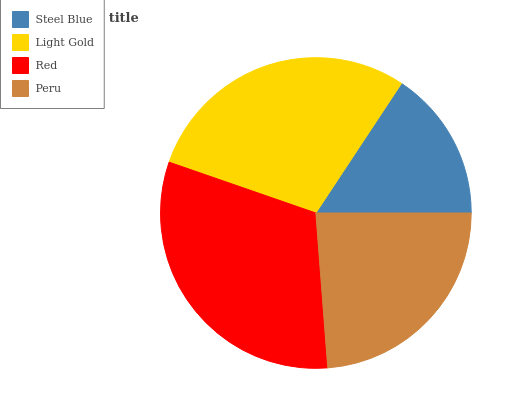Is Steel Blue the minimum?
Answer yes or no. Yes. Is Red the maximum?
Answer yes or no. Yes. Is Light Gold the minimum?
Answer yes or no. No. Is Light Gold the maximum?
Answer yes or no. No. Is Light Gold greater than Steel Blue?
Answer yes or no. Yes. Is Steel Blue less than Light Gold?
Answer yes or no. Yes. Is Steel Blue greater than Light Gold?
Answer yes or no. No. Is Light Gold less than Steel Blue?
Answer yes or no. No. Is Light Gold the high median?
Answer yes or no. Yes. Is Peru the low median?
Answer yes or no. Yes. Is Steel Blue the high median?
Answer yes or no. No. Is Red the low median?
Answer yes or no. No. 